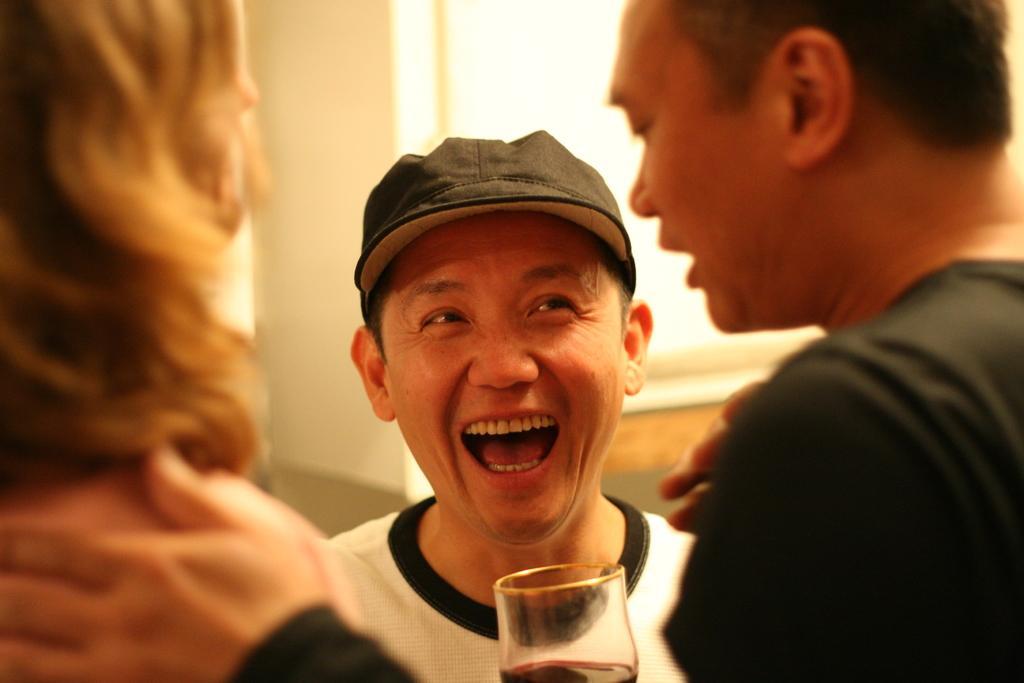Please provide a concise description of this image. this picture there are people in the center of the image and there is a glass at the bottom side of the image and there is a window in the background area of the image. 